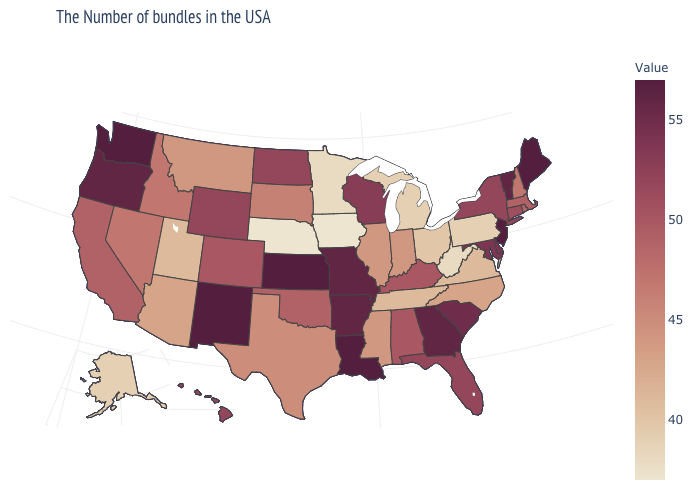Among the states that border Colorado , which have the lowest value?
Concise answer only. Nebraska. Among the states that border New Mexico , does Colorado have the highest value?
Quick response, please. Yes. Which states have the lowest value in the USA?
Be succinct. Iowa, Nebraska. Is the legend a continuous bar?
Concise answer only. Yes. Does Massachusetts have the lowest value in the Northeast?
Quick response, please. No. Does North Dakota have the highest value in the USA?
Concise answer only. No. 